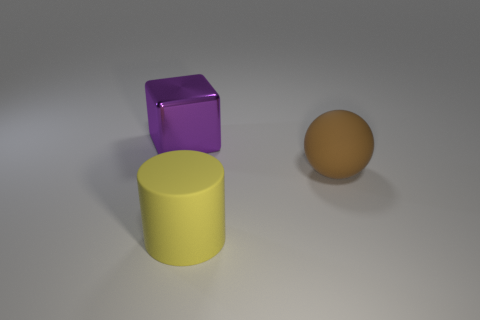Add 1 yellow cylinders. How many objects exist? 4 Subtract all cylinders. How many objects are left? 2 Subtract all brown balls. Subtract all tiny green matte things. How many objects are left? 2 Add 3 metal blocks. How many metal blocks are left? 4 Add 1 large purple things. How many large purple things exist? 2 Subtract 0 red cylinders. How many objects are left? 3 